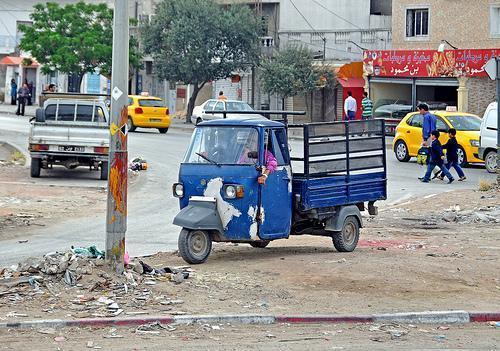How many poles are there?
Give a very brief answer. 1. 